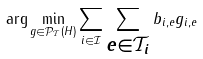Convert formula to latex. <formula><loc_0><loc_0><loc_500><loc_500>\arg \min _ { g \in \mathcal { P } _ { \mathcal { T } } ( H ) } \sum _ { i \in \mathcal { I } } \sum _ { \substack { e \in \mathcal { T } _ { i } } } b _ { i , e } g _ { i , e }</formula> 